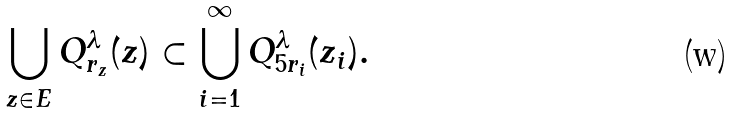<formula> <loc_0><loc_0><loc_500><loc_500>\bigcup _ { z \in E } Q _ { r _ { z } } ^ { \lambda } ( z ) \subset \bigcup _ { i = 1 } ^ { \infty } Q _ { 5 r _ { i } } ^ { \lambda } ( z _ { i } ) .</formula> 